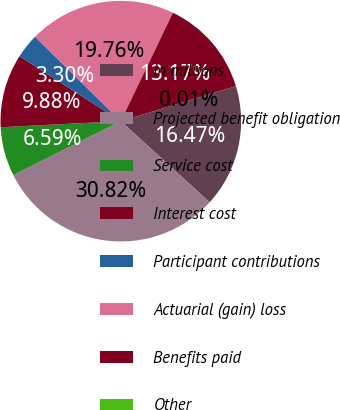Convert chart to OTSL. <chart><loc_0><loc_0><loc_500><loc_500><pie_chart><fcel>in millions<fcel>Projected benefit obligation<fcel>Service cost<fcel>Interest cost<fcel>Participant contributions<fcel>Actuarial (gain) loss<fcel>Benefits paid<fcel>Other<nl><fcel>16.47%<fcel>30.82%<fcel>6.59%<fcel>9.88%<fcel>3.3%<fcel>19.76%<fcel>13.17%<fcel>0.01%<nl></chart> 